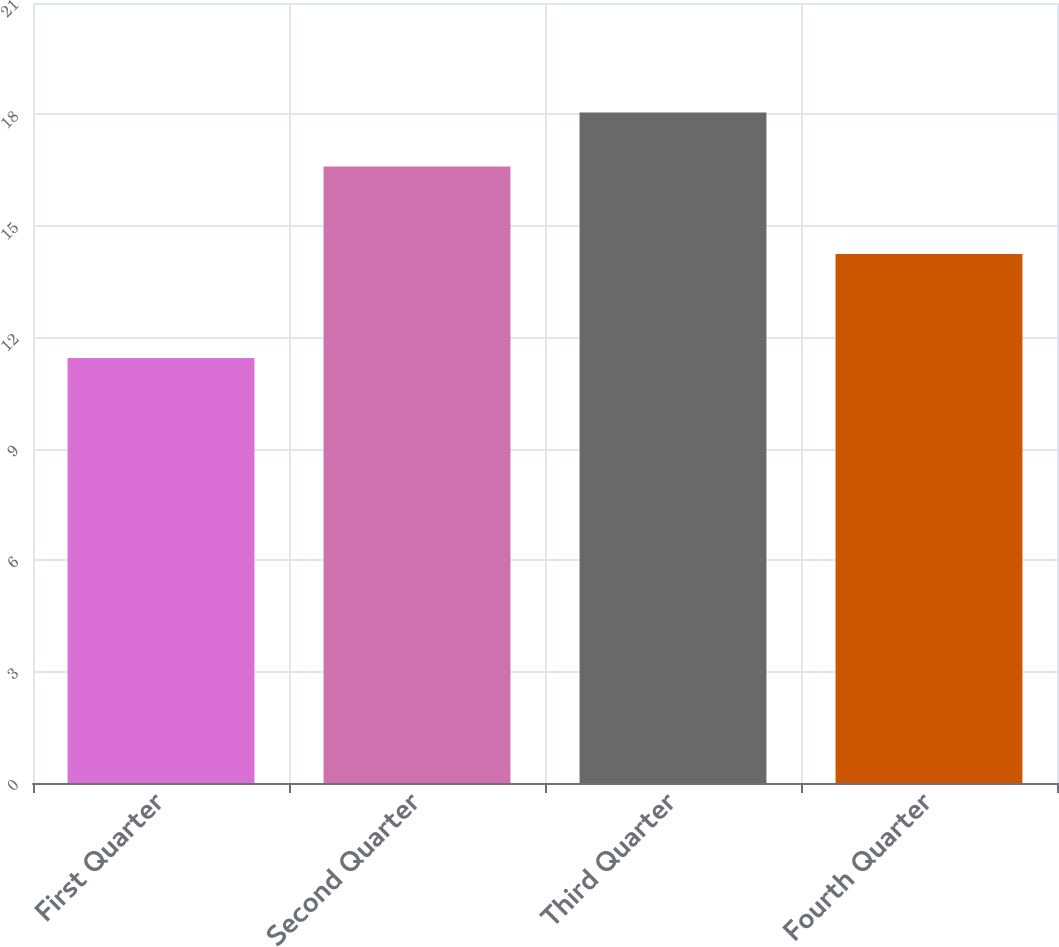Convert chart to OTSL. <chart><loc_0><loc_0><loc_500><loc_500><bar_chart><fcel>First Quarter<fcel>Second Quarter<fcel>Third Quarter<fcel>Fourth Quarter<nl><fcel>11.44<fcel>16.6<fcel>18.05<fcel>14.24<nl></chart> 